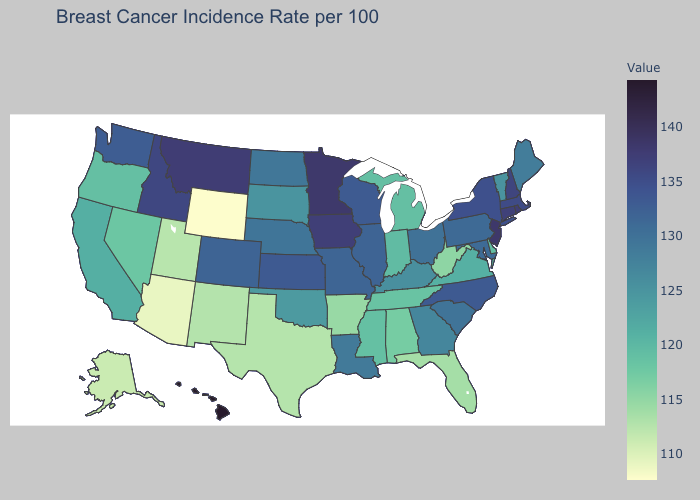Does New Jersey have the lowest value in the Northeast?
Answer briefly. No. Does the map have missing data?
Give a very brief answer. No. Among the states that border Virginia , does West Virginia have the highest value?
Be succinct. No. Does Arkansas have the lowest value in the South?
Write a very short answer. No. Is the legend a continuous bar?
Answer briefly. Yes. Does Hawaii have the lowest value in the West?
Be succinct. No. Among the states that border Georgia , does North Carolina have the highest value?
Keep it brief. Yes. 